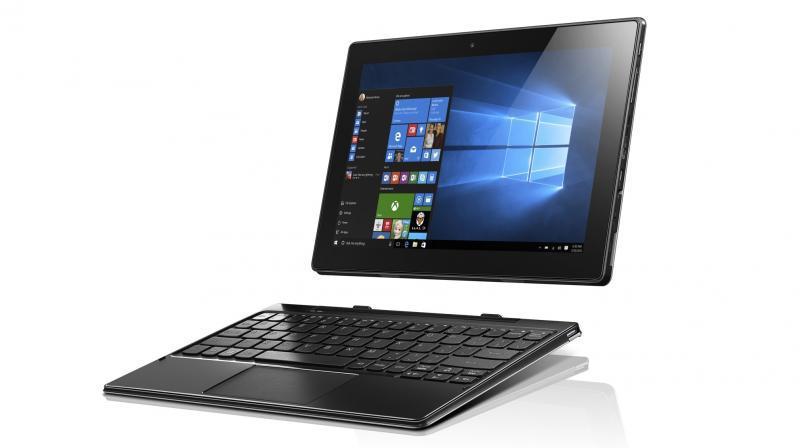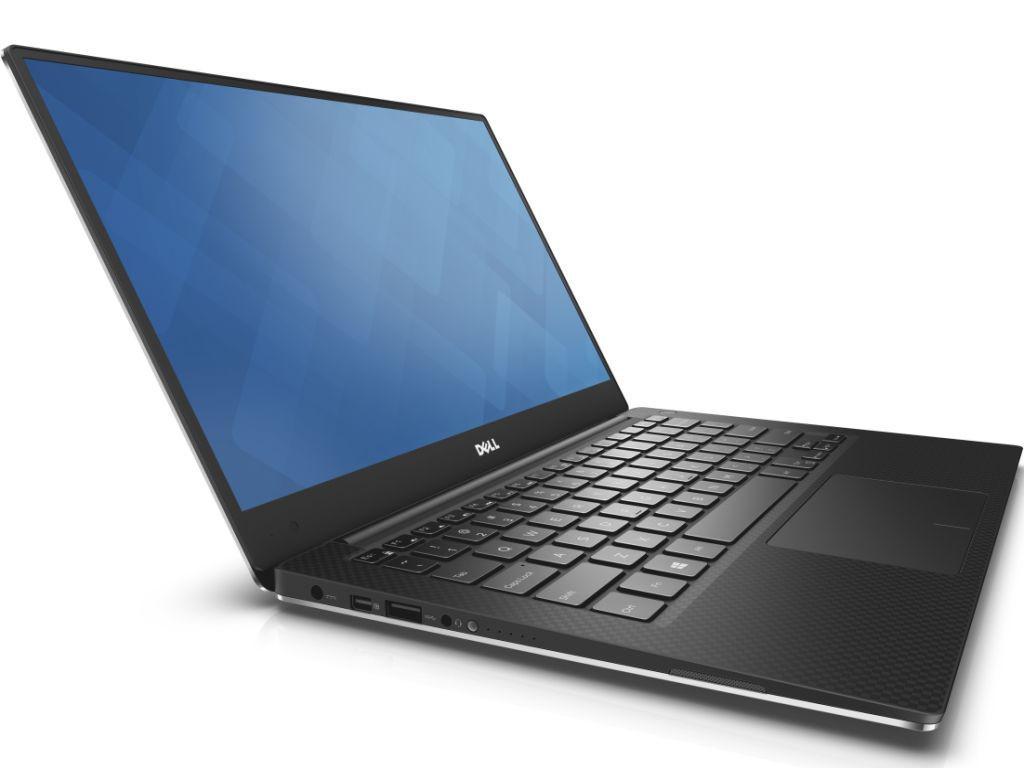The first image is the image on the left, the second image is the image on the right. Analyze the images presented: Is the assertion "The left image contains at least two laptop computers." valid? Answer yes or no. No. The first image is the image on the left, the second image is the image on the right. Considering the images on both sides, is "One laptop is shown with the monitor and keyboard disconnected from each other." valid? Answer yes or no. Yes. 